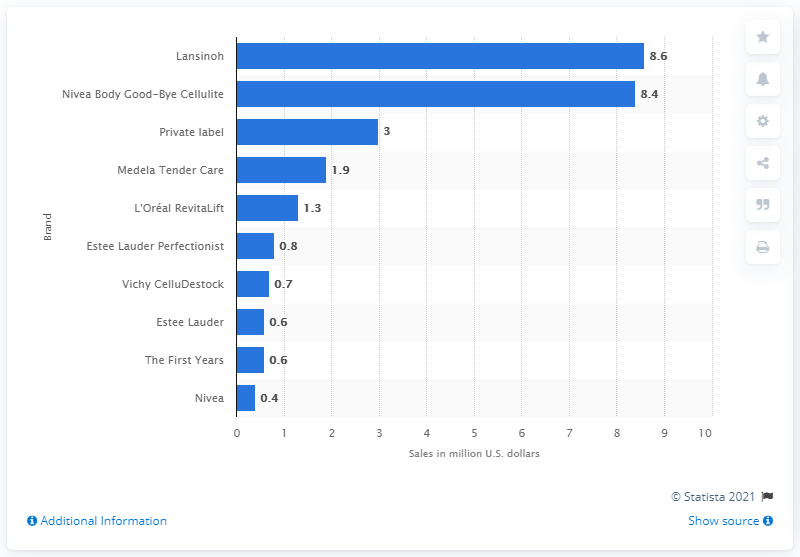Outline some significant characteristics in this image. In 2013, the sales of Lansinoh in the US were 8.6 million dollars. In 2013, Lansinoh was the leading body anti-aging product brand in the United States. 